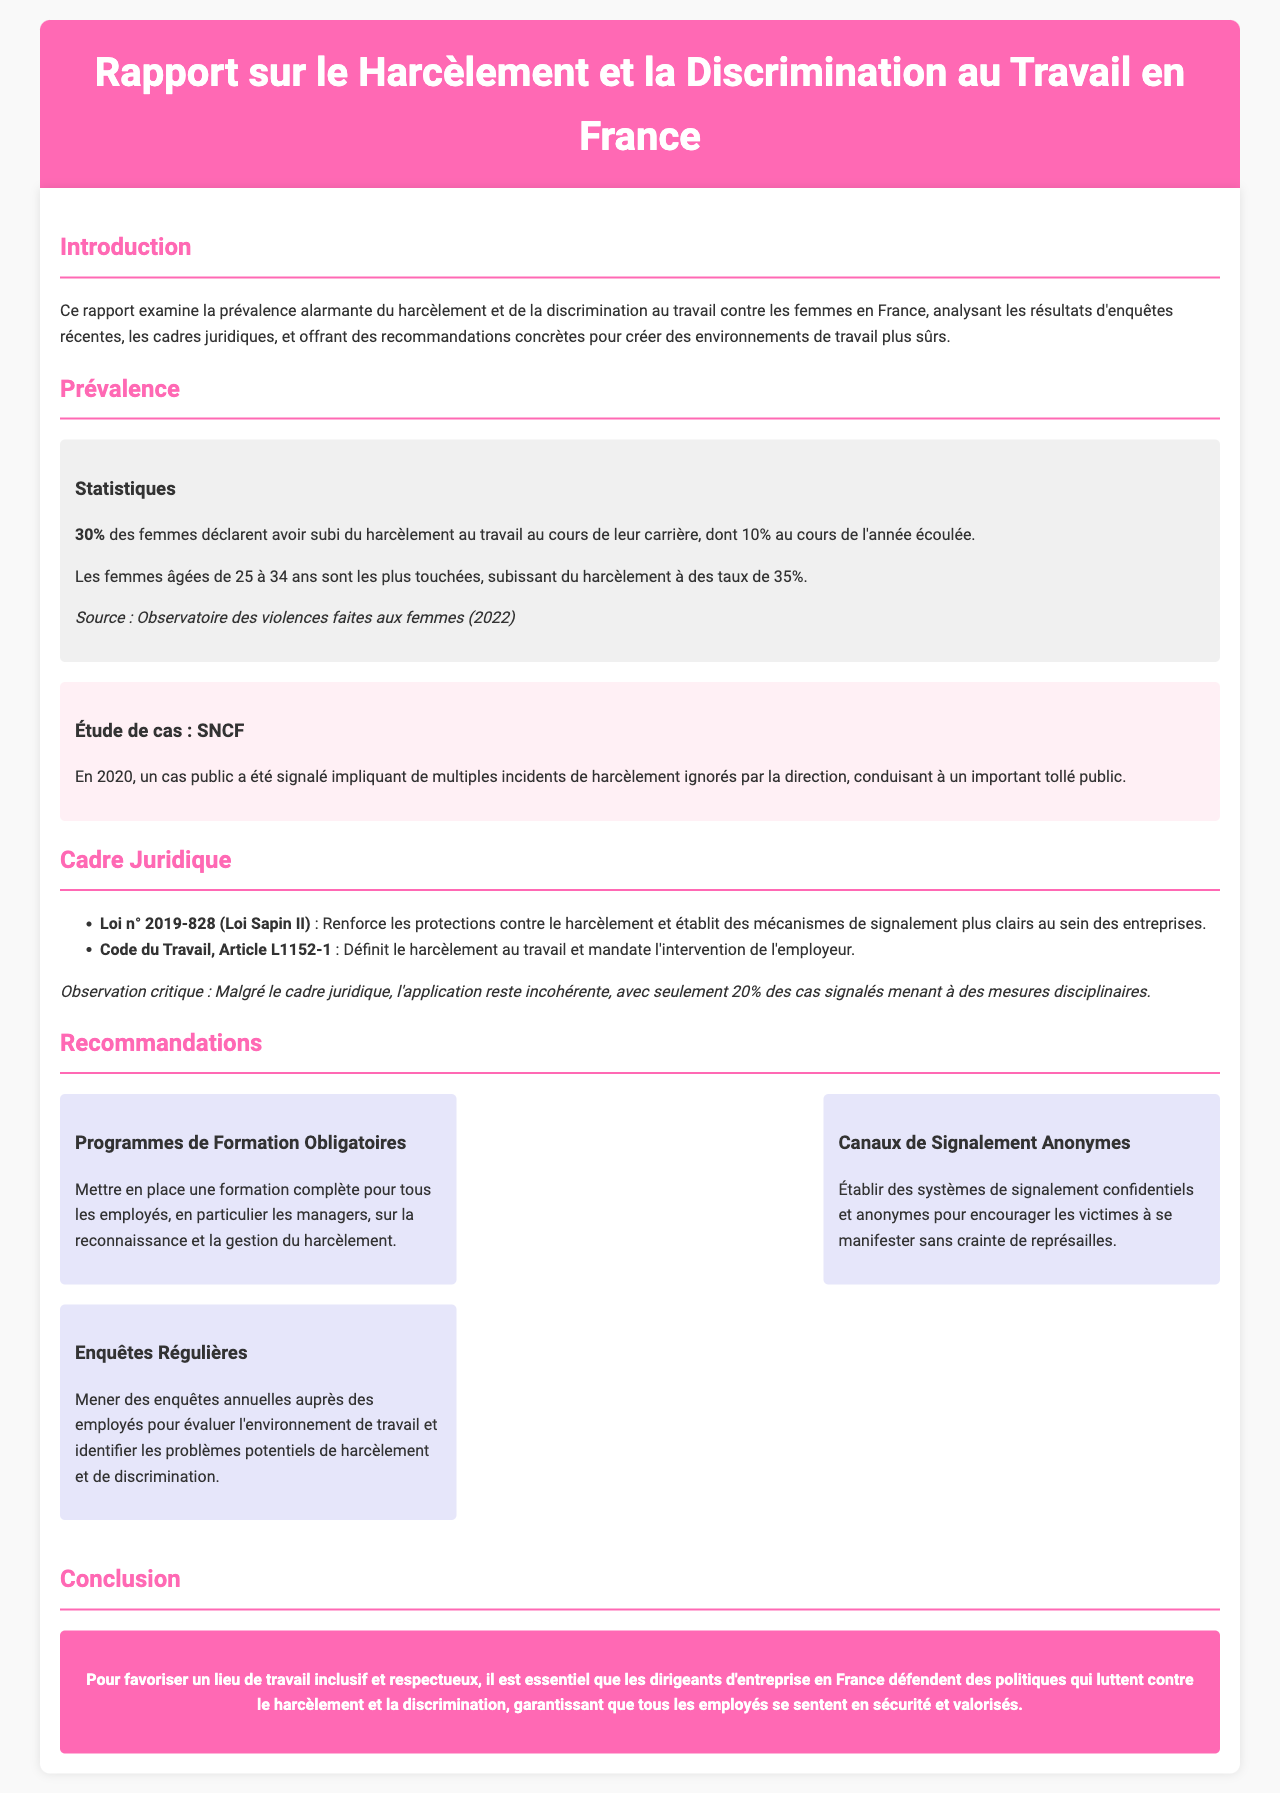Quelle est la prévalence du harcèlement au travail pour les femmes en France ? Le document indique que 30% des femmes déclarent avoir subi du harcèlement au travail au cours de leur carrière.
Answer: 30% Quel groupe d'âge est le plus touché par le harcèlement ? Selon le rapport, les femmes âgées de 25 à 34 ans subissent du harcèlement à des taux de 35%.
Answer: 35% Quelle loi renforce les protections contre le harcèlement ? La loi n° 2019-828, également connue sous le nom de Loi Sapin II, renforce les protections contre le harcèlement.
Answer: Loi n° 2019-828 Quel pourcentage de cas de harcèlement signalés aboutissent à des mesures disciplinaires ? Le rapport souligne que seulement 20% des cas signalés mènent à des mesures disciplinaires.
Answer: 20% Quelles recommandations sont proposées pour améliorer la situation ? Le rapport recommande la mise en place de programmes de formation obligatoires, des canaux de signalement anonymes et des enquêtes régulières.
Answer: Programmes de formation obligatoires, canaux de signalement anonymes, enquêtes régulières Quel est l'objectif principal de ce rapport ? L'objectif principal est de créer des environnements de travail plus sûrs en luttant contre le harcèlement et la discrimination.
Answer: Créer des environnements de travail plus sûrs Qui a réalisé l'étude de cas mentionnée dans le rapport ? Le rapport mentionne une étude de cas impliquant la SNCF.
Answer: SNCF Quelle est la couleur de l'en-tête du rapport ? L'en-tête du rapport est d'une couleur rose, spécifiquement le code couleur #FF69B4.
Answer: rose 